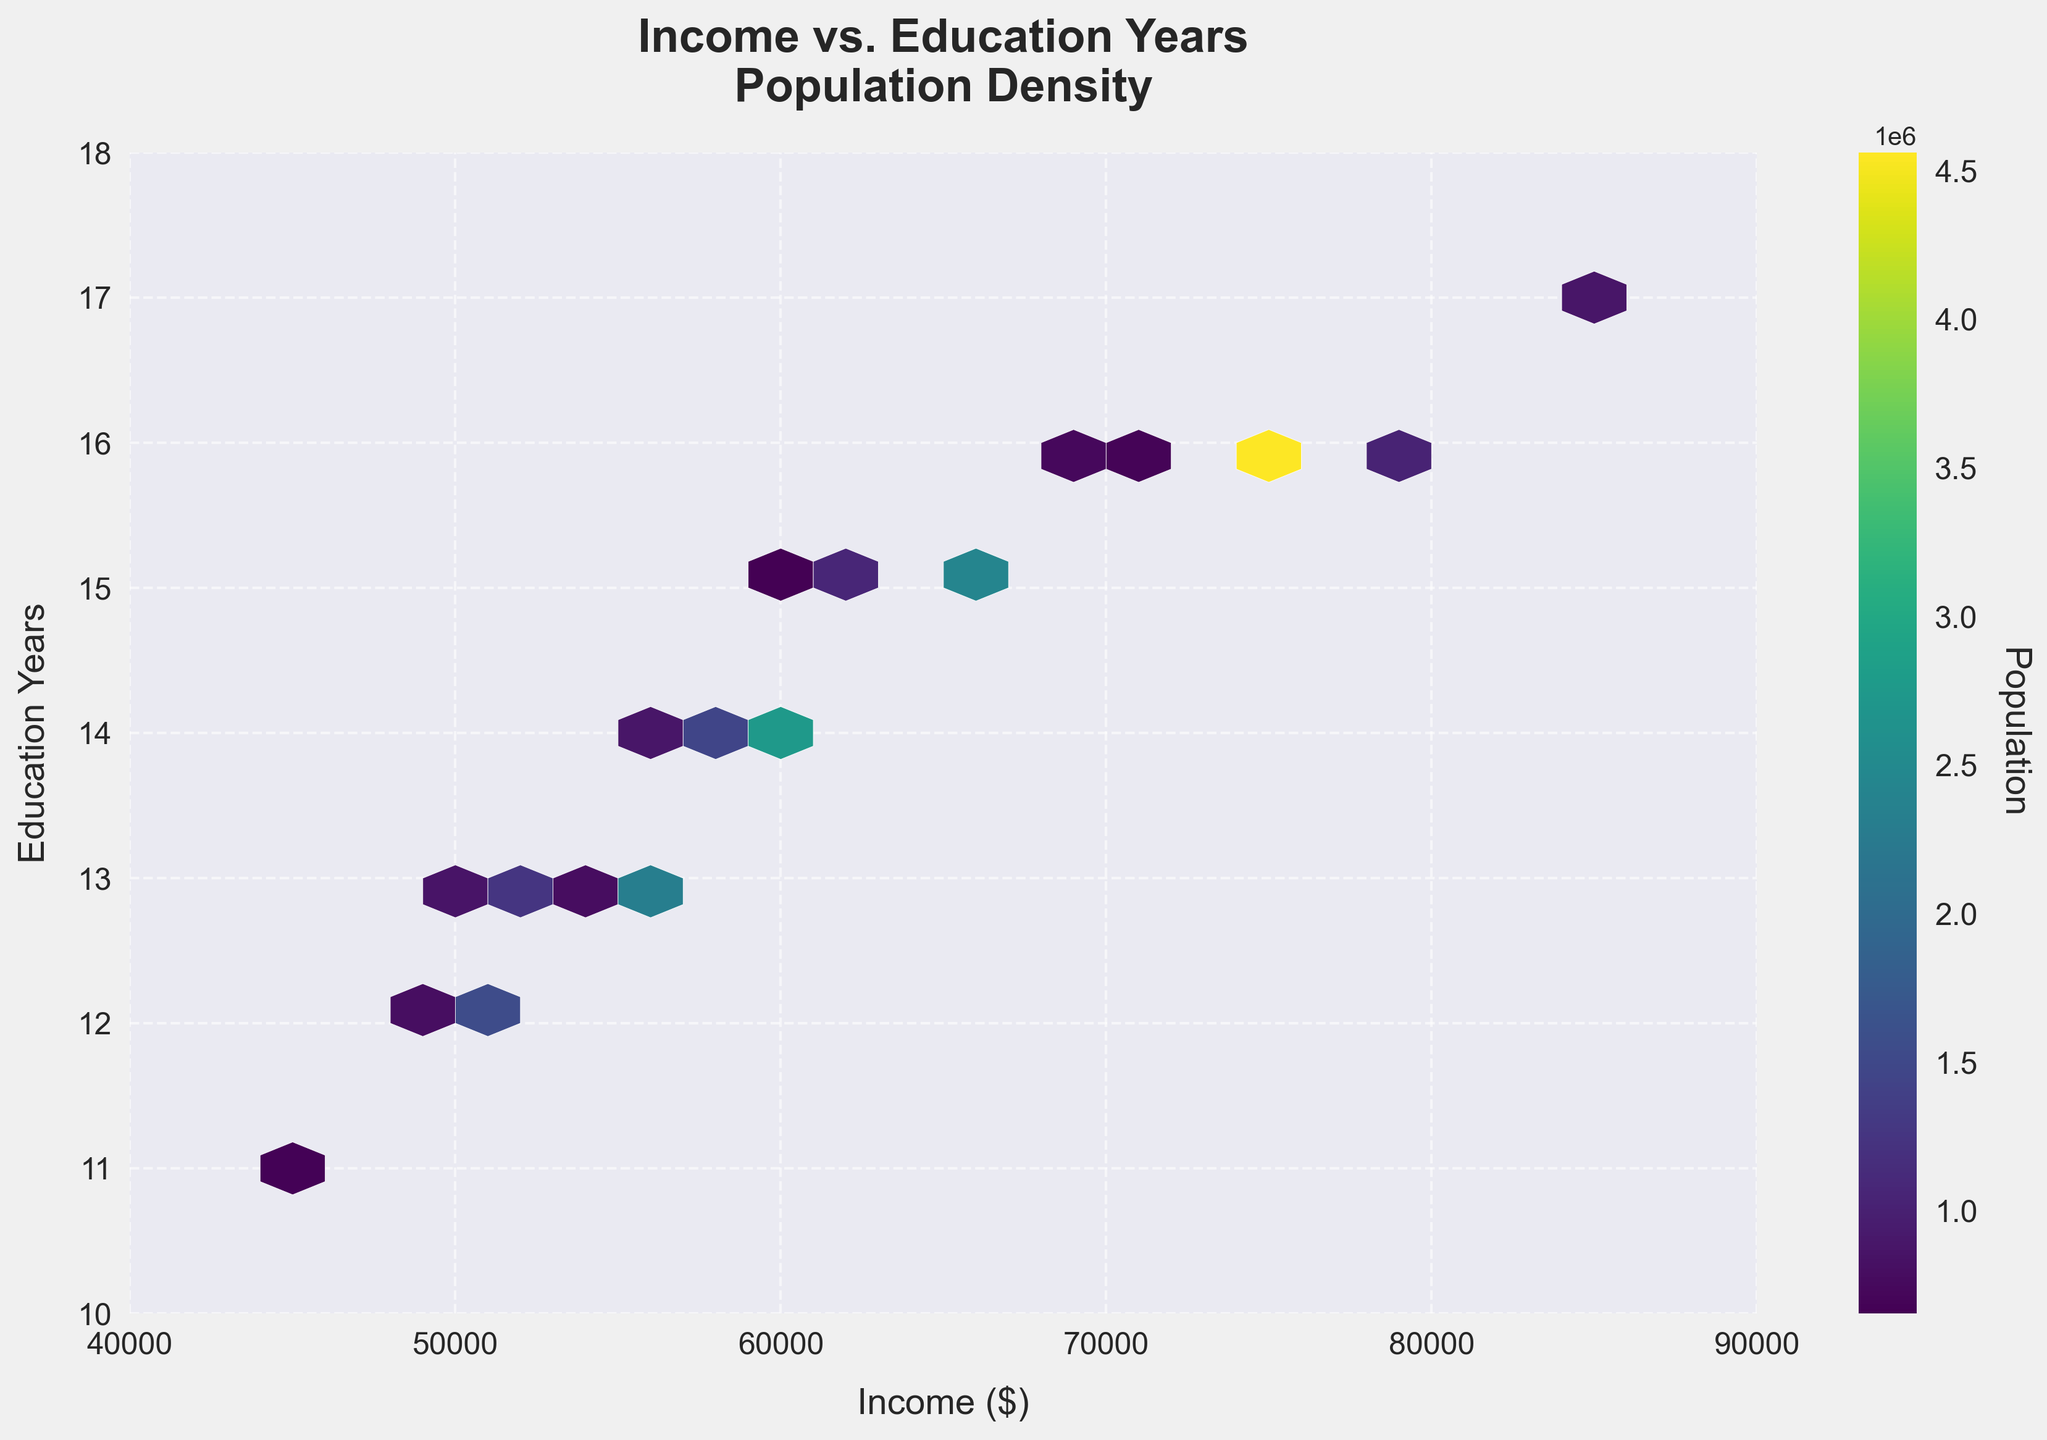What does the title of the hexbin plot tell you? The title "Income vs. Education Years\nPopulation Density" indicates that the hexbin plot displays the relationship between income and years of education, with population density represented by the color intensity of the hexagons.
Answer: Relationship between income and education years, with population density What are the ranges of income and education years on the axes? The x-axis ranges from $40,000 to $90,000, while the y-axis ranges from 10 to 18 years of education.
Answer: Income: $40,000 to $90,000; Education Years: 10 to 18 Where is the highest population density located on the plot? The highest population density is represented by the hexagon(s) with the most intense color, which can be observed in the region with an income of around $75,000 and 16 years of education.
Answer: Around $75,000 income and 16 years education How does population density vary with education years and income? In general, higher population densities tend to cluster around income levels of $50,000 to $75,000 and education years of 13 to 16, with fewer data points outside of this range.
Answer: Clusters around $50,000 to $75,000 income and 13 to 16 years education Which income and education year pair appears most frequently based on the plot? By observing the most intense color on the plot, it appears that the income and education year pair around $75,000 income and 16 years of education appears most frequently.
Answer: $75,000 income and 16 years education Compare the population density of regions with incomes of $60,000 and 14 years of education with those of $75,000 and 16 years of education. Regions with incomes of $75,000 and 16 years of education have a higher population density compared to those with $60,000 and 14 years of education, as indicated by the more intense color at the $75,000 and 16 years spot.
Answer: Higher density at $75,000 income and 16 years education What can be inferred about the relationship between income and education based on the plot? Higher incomes generally correspond to more years of education, as the plot shows hexagons with higher intensities (population densities) toward higher income and education levels.
Answer: Higher income generally corresponds to more years of education Is there any region with an income below $50,000 and high population density? Based on the plot, there are no regions with an income below $50,000 that show high population density, as these hexagons are less intense.
Answer: No, there is no such region What is the color bar indicating in the hexbin plot? The color bar represents the population, with darker or more intense colors indicating higher population densities within those income and education years.
Answer: Represents population density How does the population density distribution support or contradict common socioeconomic theories? The plot shows that higher education often leads to higher income, which supports common socioeconomic theories that suggest education positively impacts earning potential. This is evidenced by the higher densities observed around higher education years and incomes.
Answer: Supports that higher education leads to higher income 